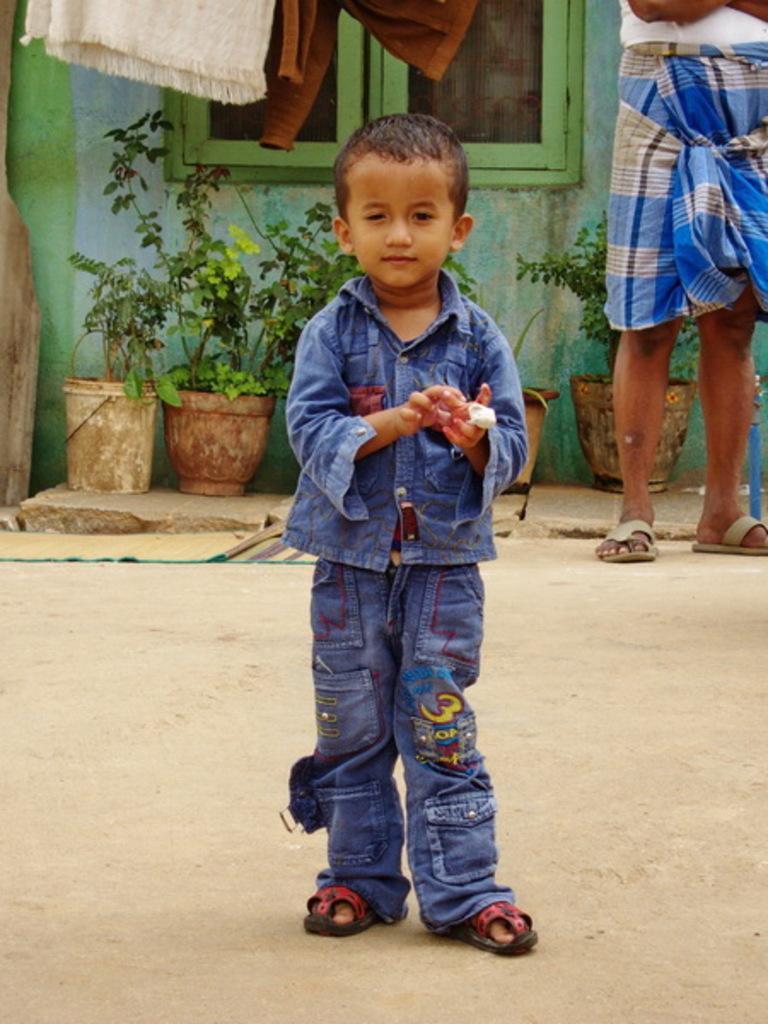Please provide a concise description of this image. In this image in the foreground there is one boy standing, and in the background there is another person, flower pots, plants, window, wall and some clothes. At the bottom there is walkway and there is one mat. 